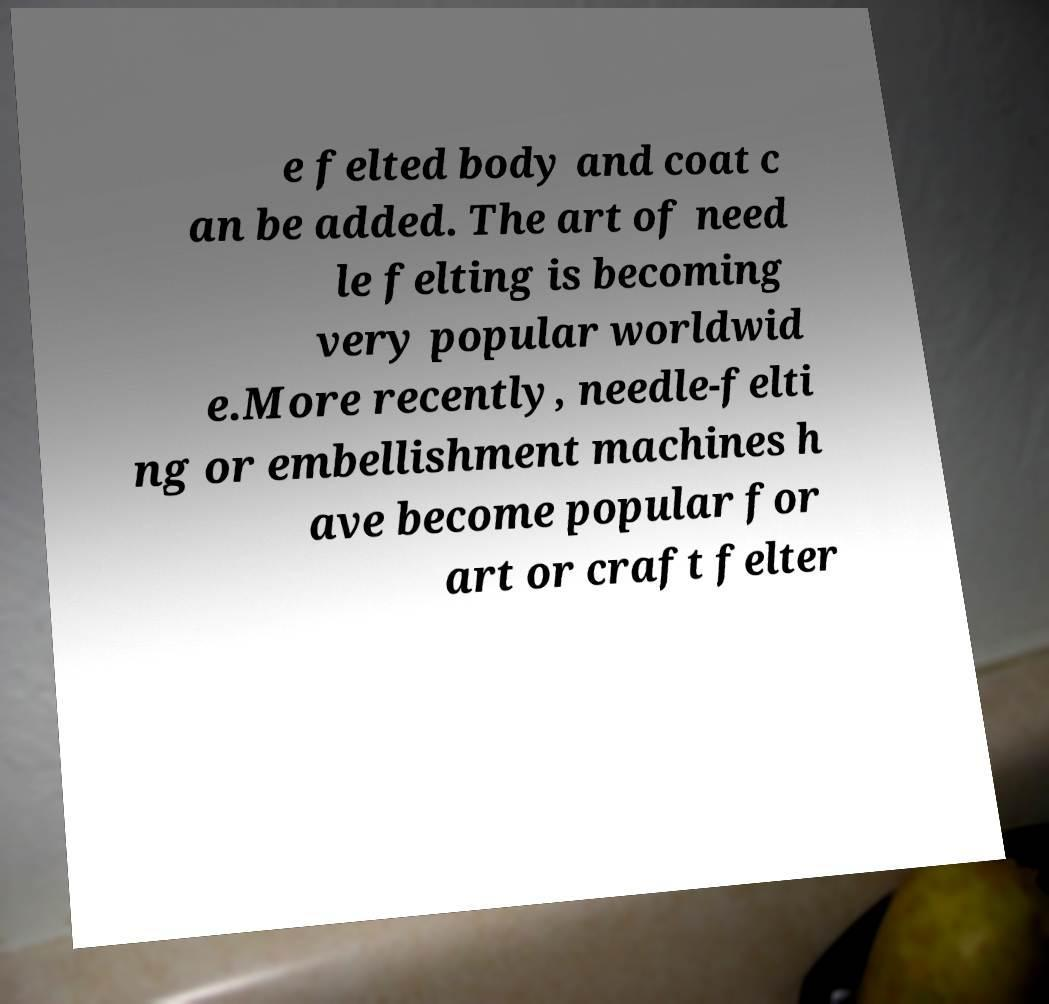What messages or text are displayed in this image? I need them in a readable, typed format. e felted body and coat c an be added. The art of need le felting is becoming very popular worldwid e.More recently, needle-felti ng or embellishment machines h ave become popular for art or craft felter 